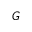<formula> <loc_0><loc_0><loc_500><loc_500>G</formula> 